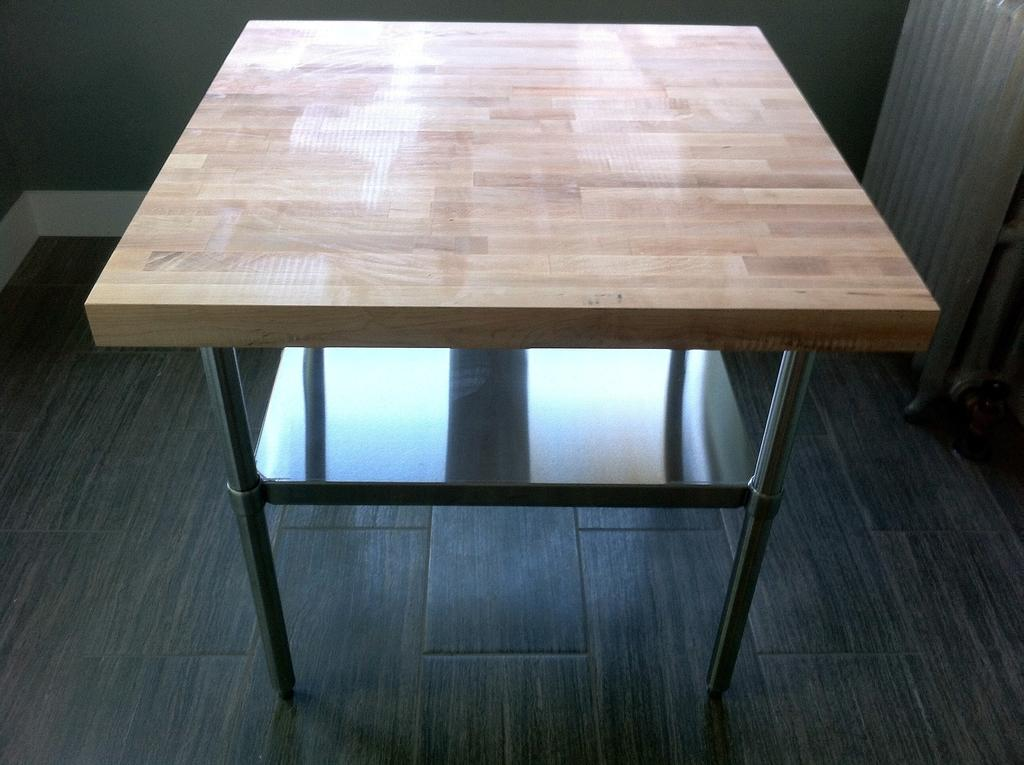What is the main object in the center of the image? There is a table in the center of the image. What can be seen in the background of the image? There is a wall in the background of the image. What type of car is parked in front of the wall in the image? There is no car present in the image; it only features a table and a wall. What day of the week is it in the image? The day of the week cannot be determined from the image, as it only shows a table and a wall. 